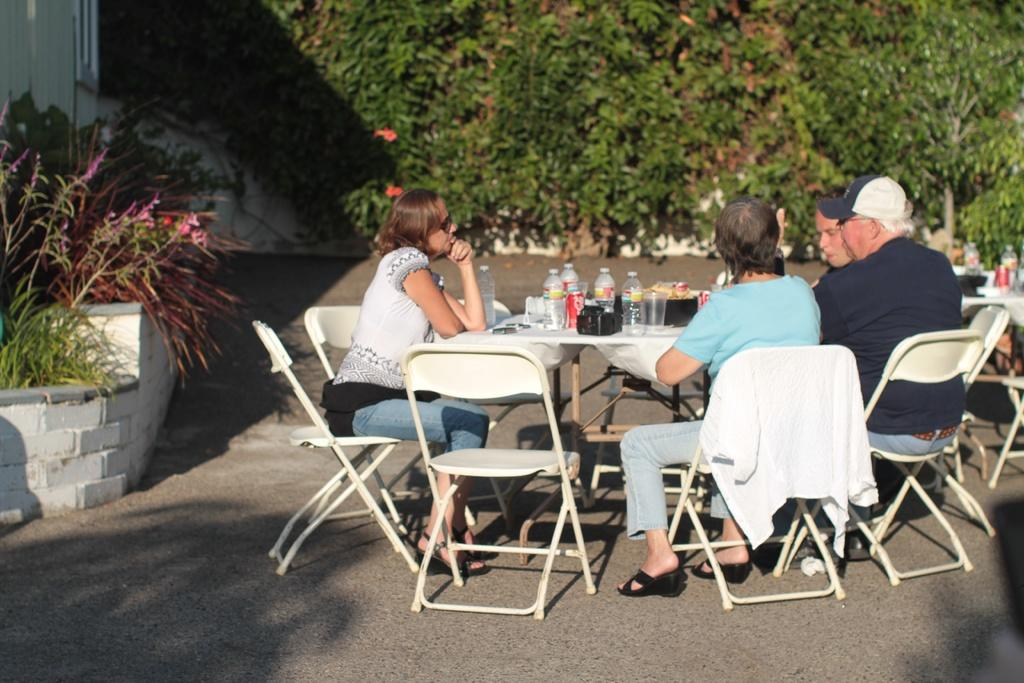Who is present at the table in the image? There are old people sitting around the table in the image. What items can be seen on the table? Water bottles, tins, and glasses are present on the table. What can be seen in the background of the image? There are plants in the background of the image. What type of humor is being shared among the old people in the image? There is no indication of humor being shared in the image; it simply shows old people sitting around a table with various items. 